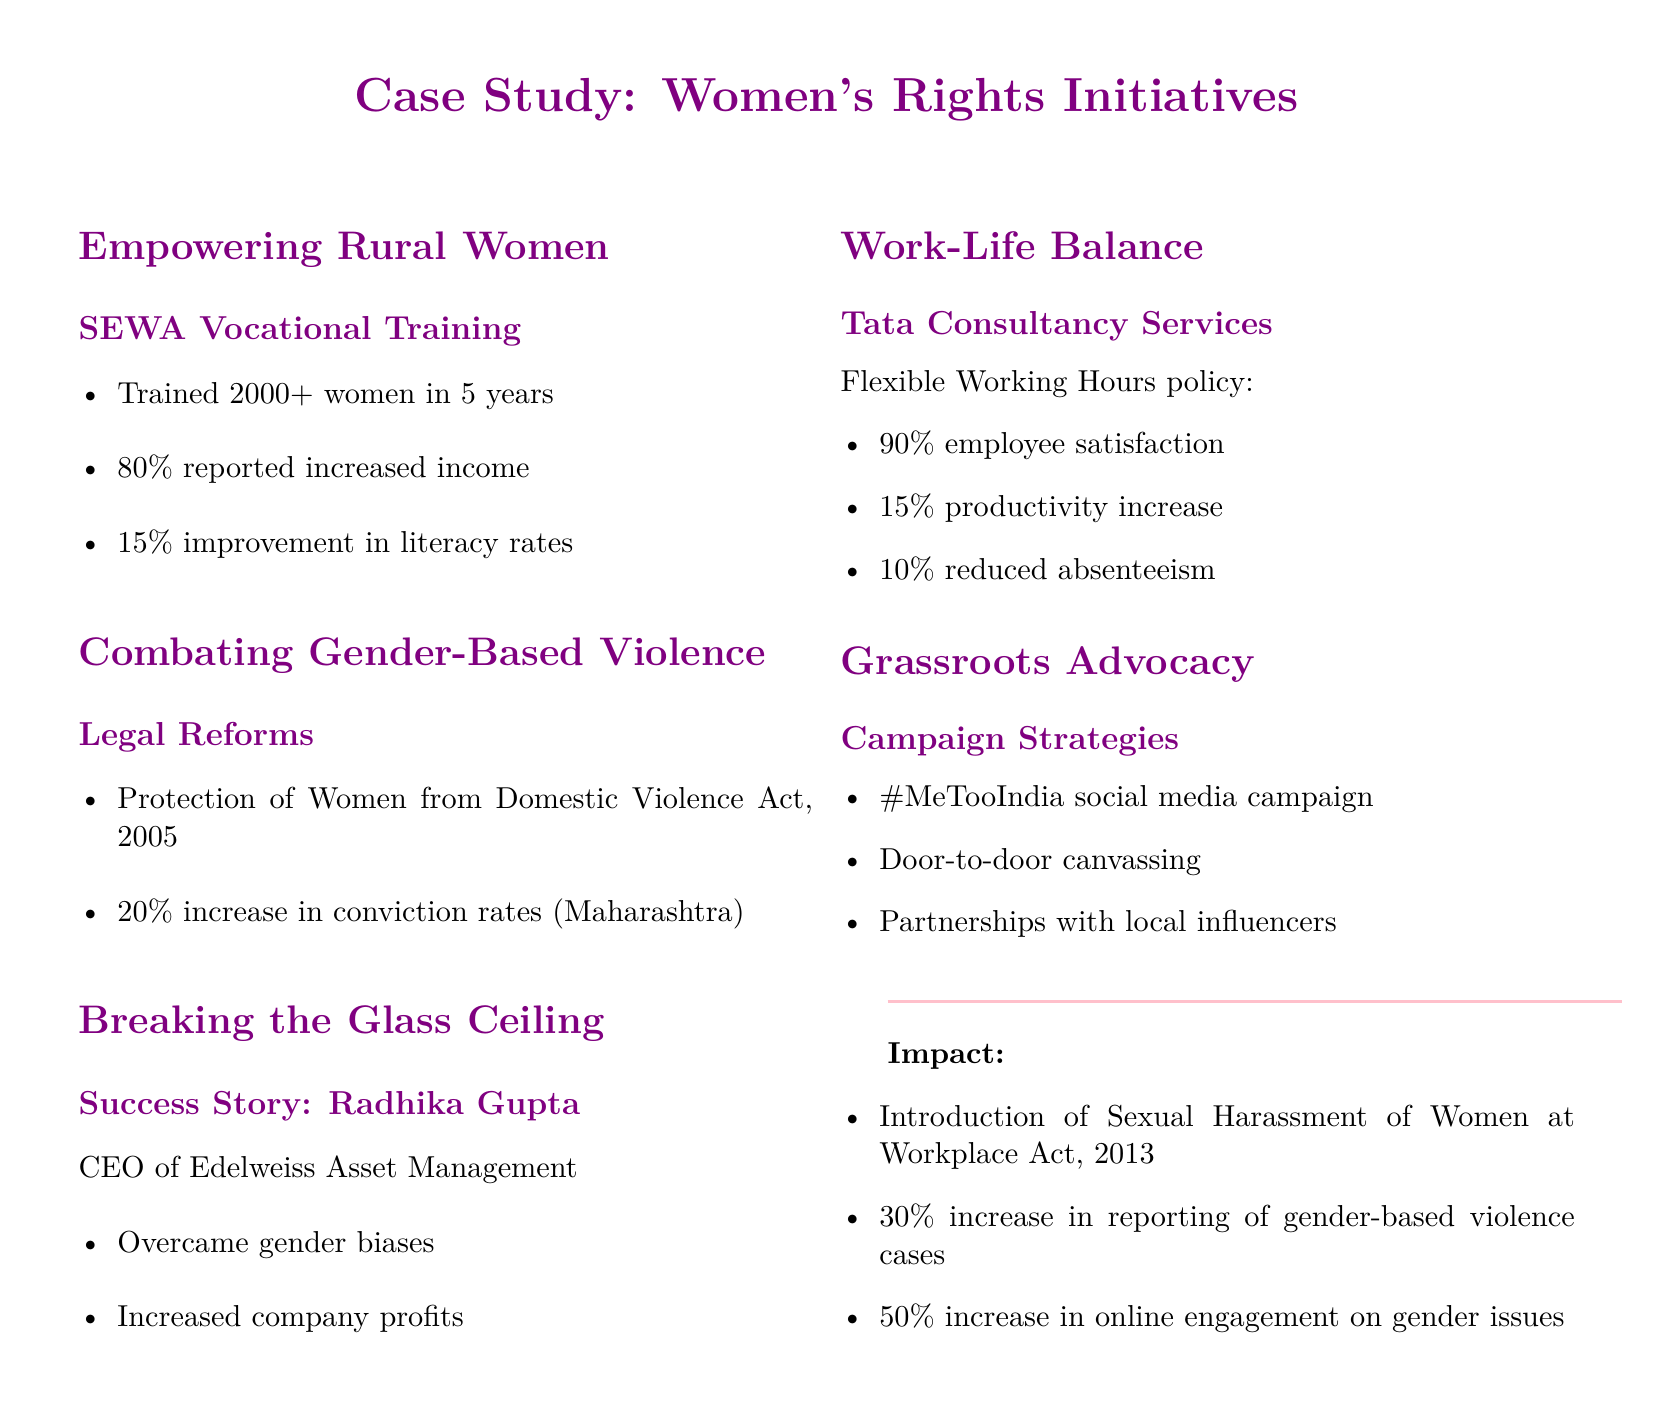What is the training completion rate of women in SEWA Vocational Training? The document states that over 2000 women were trained in 5 years, indicating high participation in the program.
Answer: 2000+ What was the reported income increase percentage among trained women? The document mentions that 80% of women reported increased income after training in SEWA Vocational Training.
Answer: 80% What legal act was introduced in 2005 to protect women from domestic violence? The case study highlights the Protection of Women from Domestic Violence Act, which is critical for legal reform.
Answer: Protection of Women from Domestic Violence Act, 2005 Who is the CEO of Edelweiss Asset Management highlighted in the case study? The document features Radhika Gupta as a success story of breaking the glass ceiling in leadership roles.
Answer: Radhika Gupta What was the productivity increase percentage at Tata Consultancy Services due to flexible working hours? The document reports a 15% increase in productivity due to the company's flexible working hours policy.
Answer: 15% What was the increase percentage in conviction rates noted in Maharashtra post-legal reforms? The case study states there was a 20% increase in conviction rates in Maharashtra after legal reforms for women.
Answer: 20% What was the employee satisfaction percentage achieved with the flexible working hours policy? The document specifies that 90% of employees were satisfied with the flexible working hours at Tata Consultancy Services.
Answer: 90% What campaign strategy involved social media engagement for gender issues? The document mentions the #MeTooIndia campaign as a critical strategy utilizing social media to raise awareness.
Answer: #MeTooIndia How much did online engagement on gender issues increase as a result of grassroots advocacy? The case study reports a 50% increase in online engagement related to gender issues.
Answer: 50% 